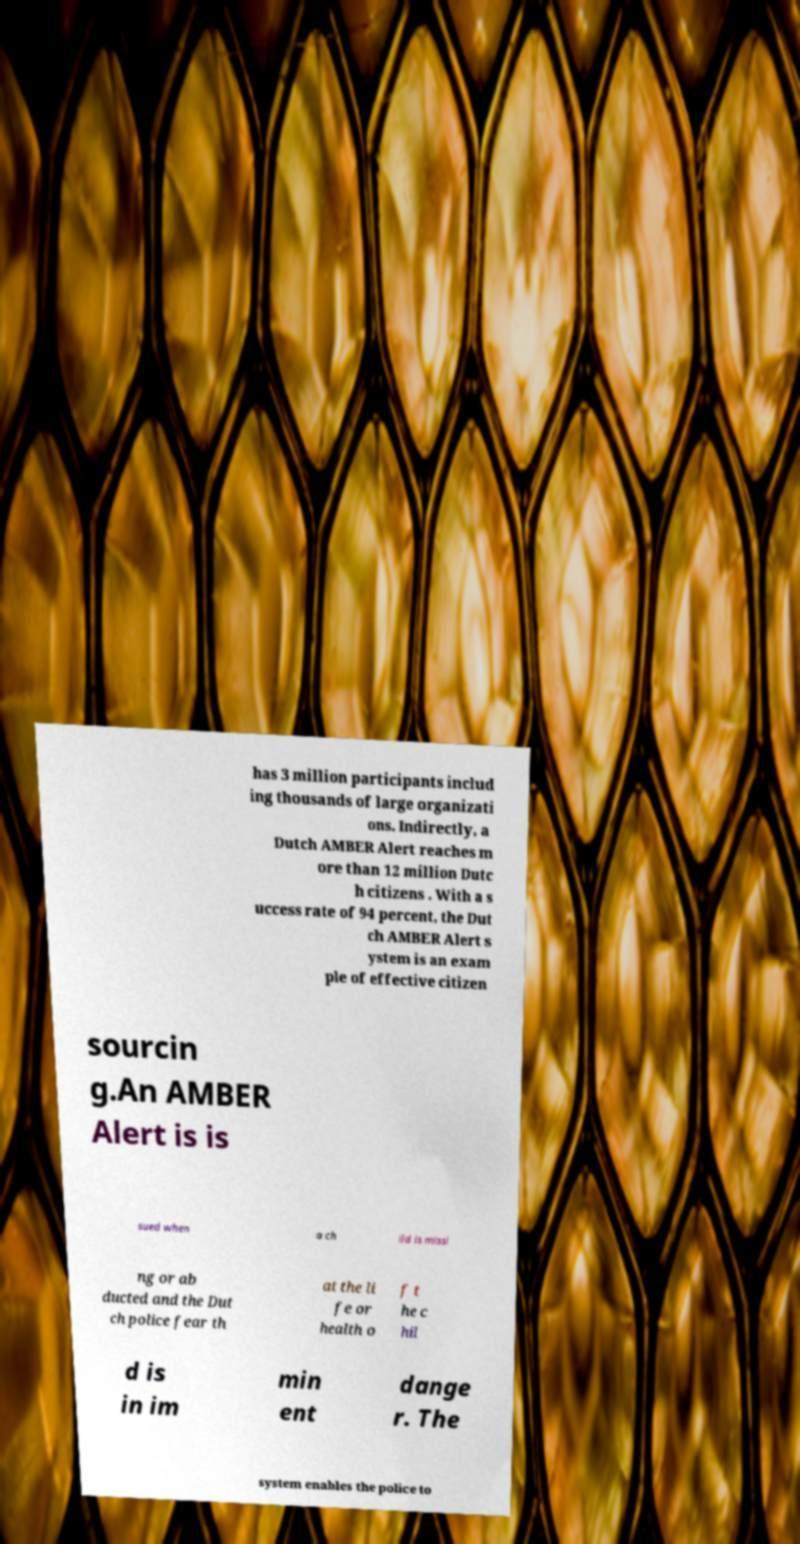Can you read and provide the text displayed in the image?This photo seems to have some interesting text. Can you extract and type it out for me? has 3 million participants includ ing thousands of large organizati ons. Indirectly, a Dutch AMBER Alert reaches m ore than 12 million Dutc h citizens . With a s uccess rate of 94 percent, the Dut ch AMBER Alert s ystem is an exam ple of effective citizen sourcin g.An AMBER Alert is is sued when a ch ild is missi ng or ab ducted and the Dut ch police fear th at the li fe or health o f t he c hil d is in im min ent dange r. The system enables the police to 